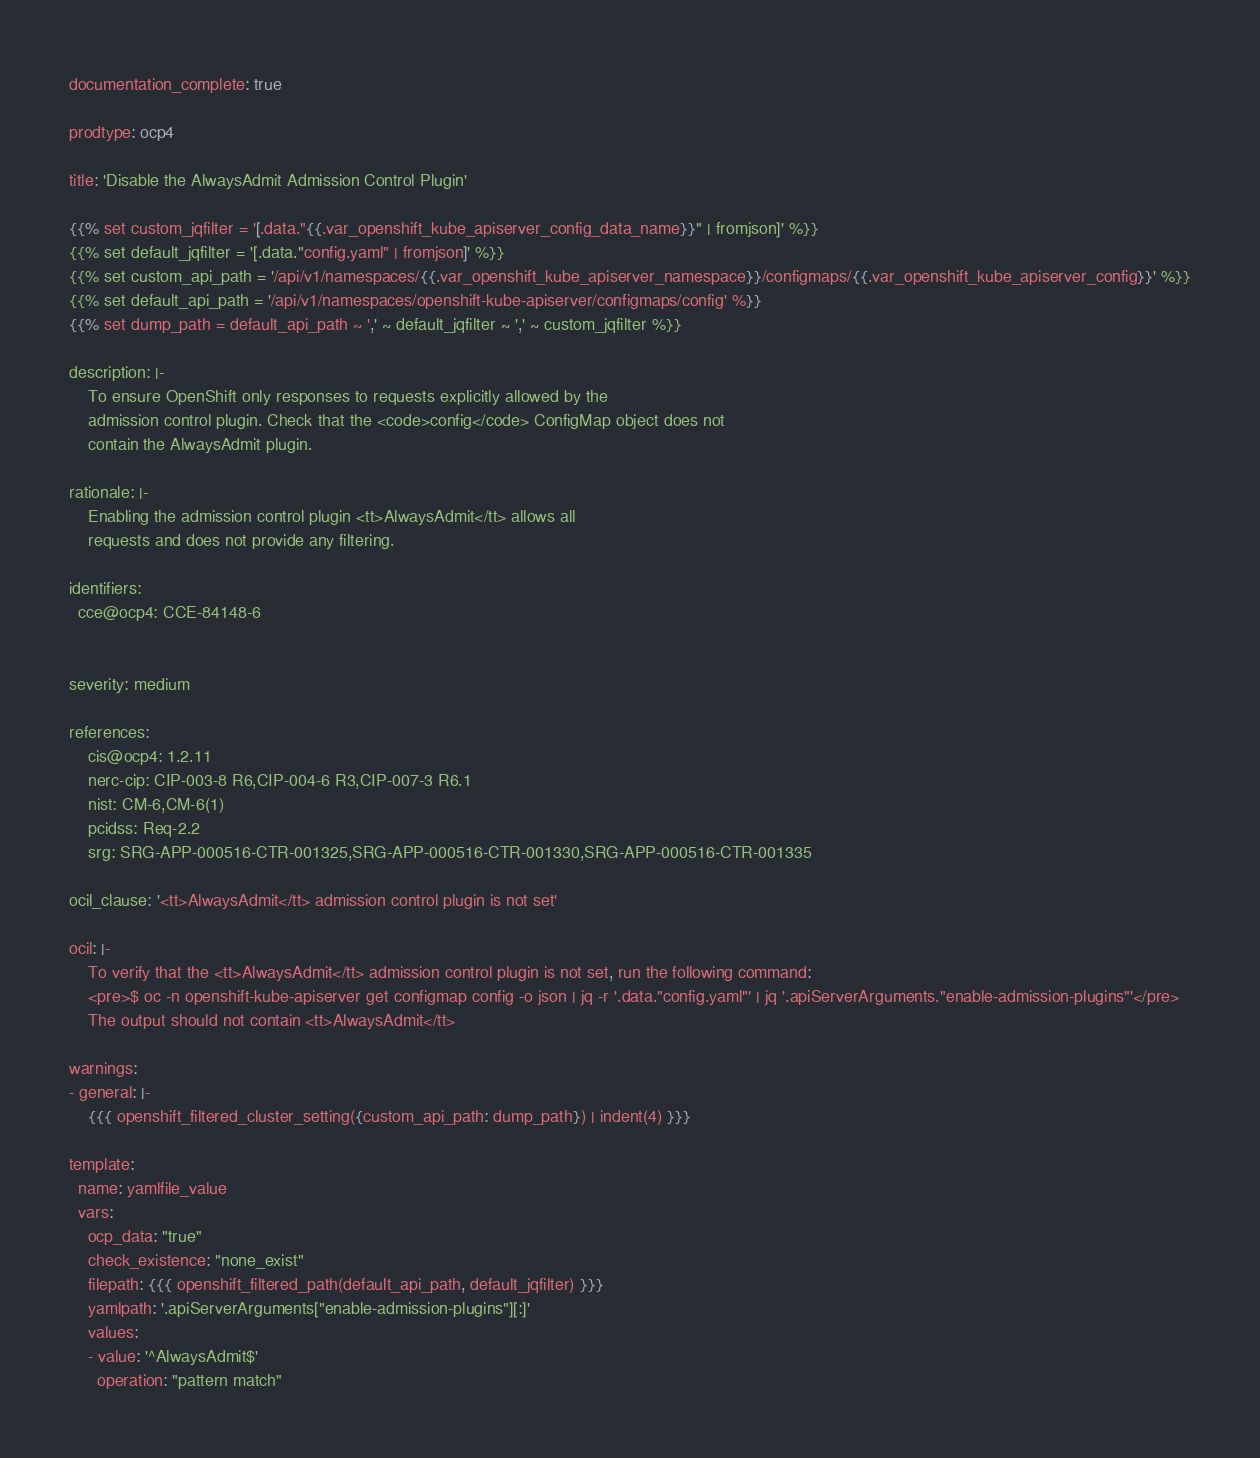<code> <loc_0><loc_0><loc_500><loc_500><_YAML_>documentation_complete: true

prodtype: ocp4

title: 'Disable the AlwaysAdmit Admission Control Plugin'

{{% set custom_jqfilter = '[.data."{{.var_openshift_kube_apiserver_config_data_name}}" | fromjson]' %}}
{{% set default_jqfilter = '[.data."config.yaml" | fromjson]' %}}
{{% set custom_api_path = '/api/v1/namespaces/{{.var_openshift_kube_apiserver_namespace}}/configmaps/{{.var_openshift_kube_apiserver_config}}' %}}
{{% set default_api_path = '/api/v1/namespaces/openshift-kube-apiserver/configmaps/config' %}}
{{% set dump_path = default_api_path ~ ',' ~ default_jqfilter ~ ',' ~ custom_jqfilter %}}

description: |-
    To ensure OpenShift only responses to requests explicitly allowed by the
    admission control plugin. Check that the <code>config</code> ConfigMap object does not
    contain the AlwaysAdmit plugin.

rationale: |-
    Enabling the admission control plugin <tt>AlwaysAdmit</tt> allows all
    requests and does not provide any filtering.

identifiers:
  cce@ocp4: CCE-84148-6


severity: medium

references:
    cis@ocp4: 1.2.11
    nerc-cip: CIP-003-8 R6,CIP-004-6 R3,CIP-007-3 R6.1
    nist: CM-6,CM-6(1)
    pcidss: Req-2.2
    srg: SRG-APP-000516-CTR-001325,SRG-APP-000516-CTR-001330,SRG-APP-000516-CTR-001335

ocil_clause: '<tt>AlwaysAdmit</tt> admission control plugin is not set'

ocil: |-
    To verify that the <tt>AlwaysAdmit</tt> admission control plugin is not set, run the following command:
    <pre>$ oc -n openshift-kube-apiserver get configmap config -o json | jq -r '.data."config.yaml"' | jq '.apiServerArguments."enable-admission-plugins"'</pre>
    The output should not contain <tt>AlwaysAdmit</tt>

warnings:
- general: |-
    {{{ openshift_filtered_cluster_setting({custom_api_path: dump_path}) | indent(4) }}}

template:
  name: yamlfile_value
  vars:
    ocp_data: "true"
    check_existence: "none_exist"
    filepath: {{{ openshift_filtered_path(default_api_path, default_jqfilter) }}}
    yamlpath: '.apiServerArguments["enable-admission-plugins"][:]'
    values:
    - value: '^AlwaysAdmit$'
      operation: "pattern match"
</code> 